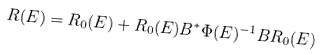Convert formula to latex. <formula><loc_0><loc_0><loc_500><loc_500>R ( E ) = R _ { 0 } ( E ) + R _ { 0 } ( E ) B ^ { * } \Phi ( E ) ^ { - 1 } B R _ { 0 } ( E )</formula> 